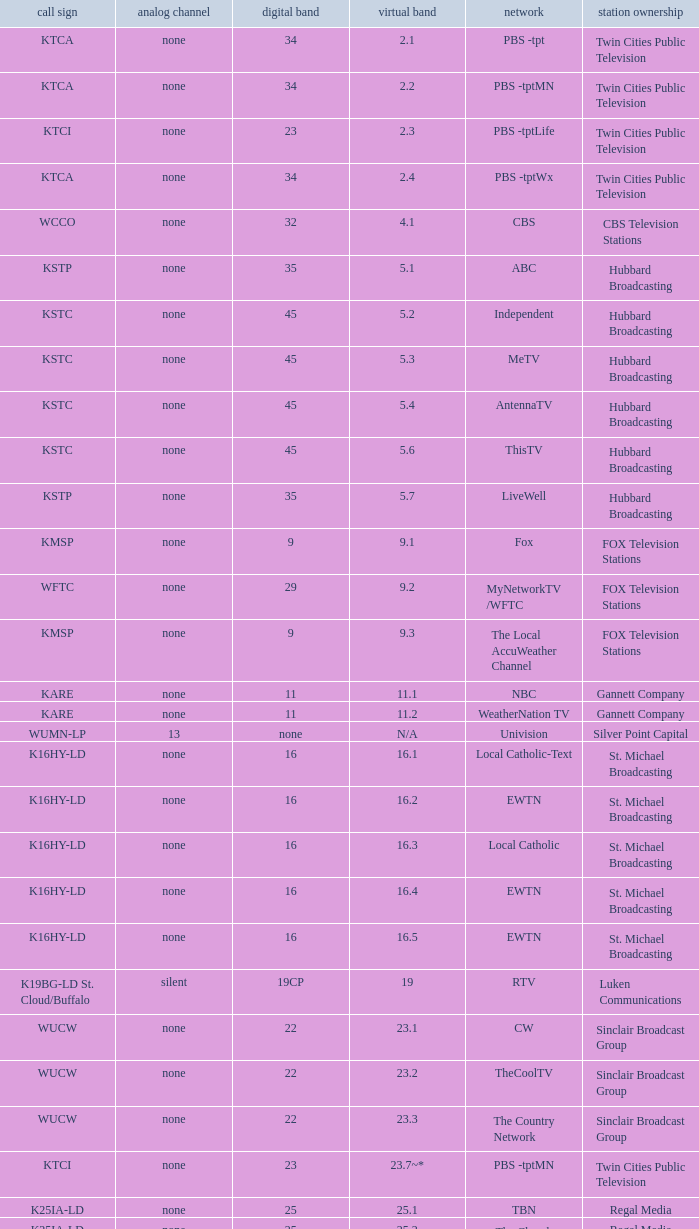Call sign of k43hb-ld is what virtual channel? 43.1. 